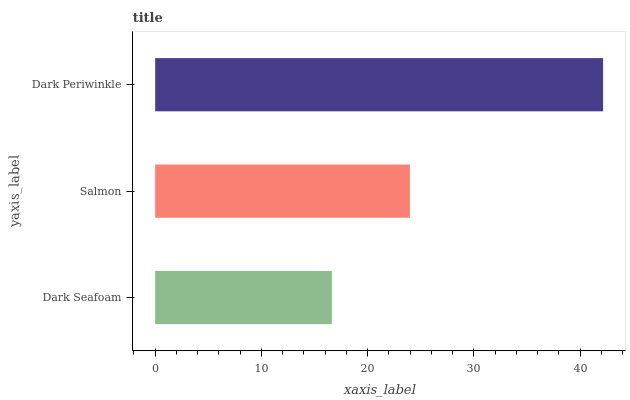Is Dark Seafoam the minimum?
Answer yes or no. Yes. Is Dark Periwinkle the maximum?
Answer yes or no. Yes. Is Salmon the minimum?
Answer yes or no. No. Is Salmon the maximum?
Answer yes or no. No. Is Salmon greater than Dark Seafoam?
Answer yes or no. Yes. Is Dark Seafoam less than Salmon?
Answer yes or no. Yes. Is Dark Seafoam greater than Salmon?
Answer yes or no. No. Is Salmon less than Dark Seafoam?
Answer yes or no. No. Is Salmon the high median?
Answer yes or no. Yes. Is Salmon the low median?
Answer yes or no. Yes. Is Dark Periwinkle the high median?
Answer yes or no. No. Is Dark Seafoam the low median?
Answer yes or no. No. 